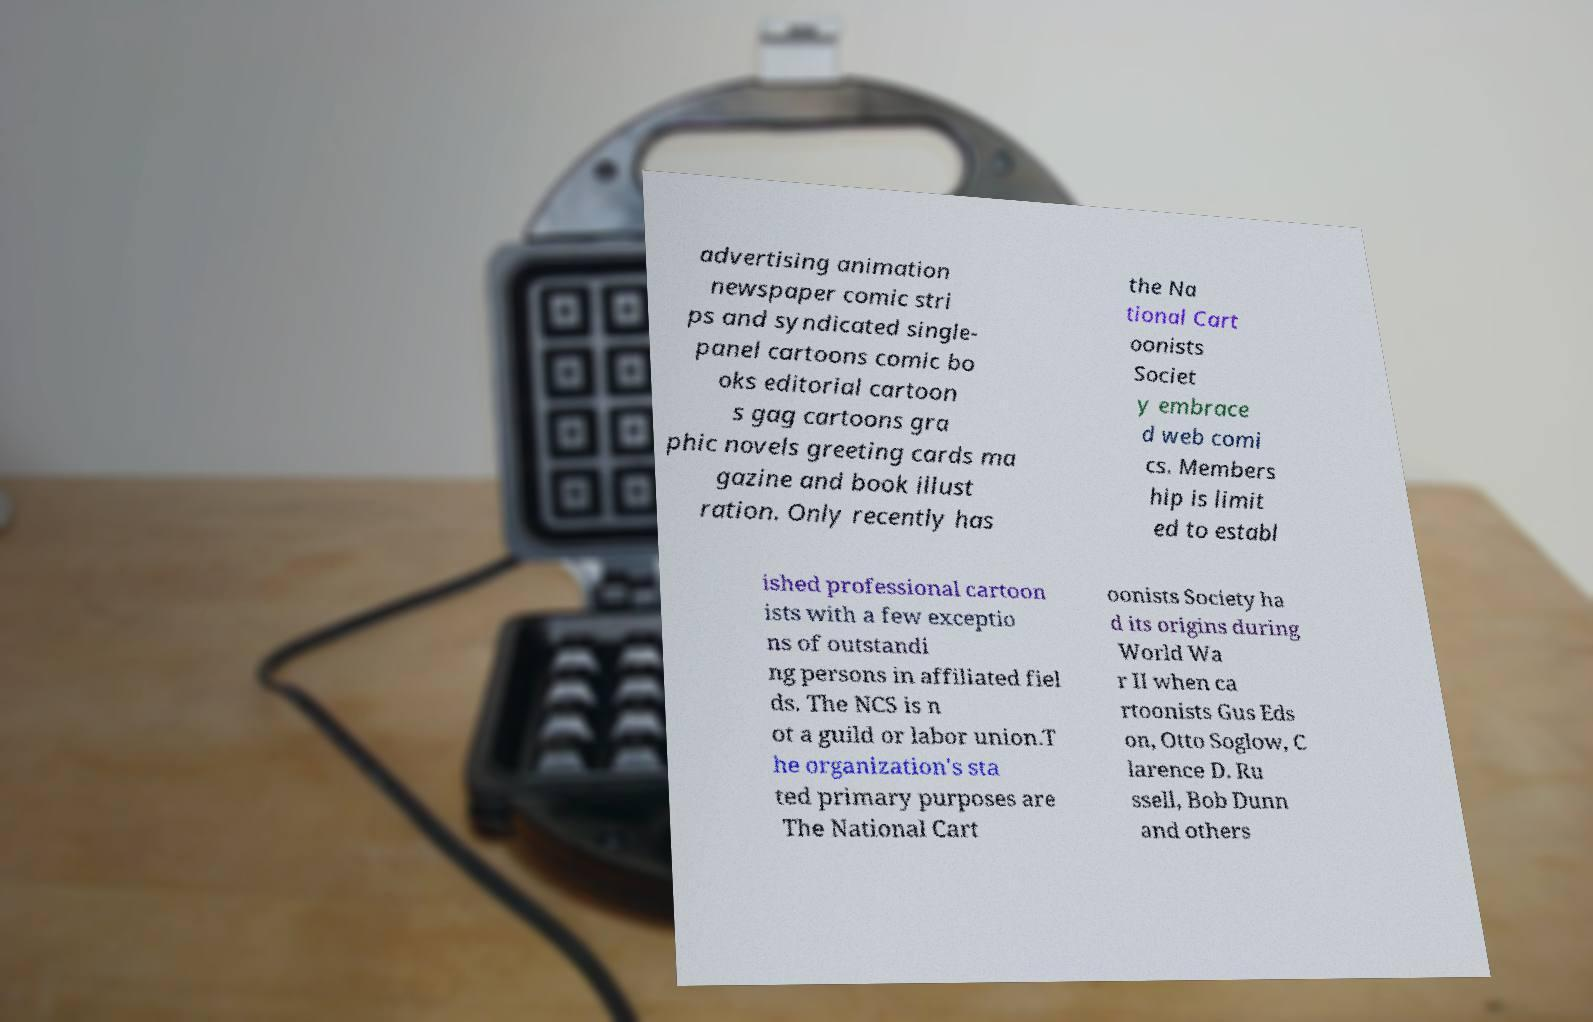Can you read and provide the text displayed in the image?This photo seems to have some interesting text. Can you extract and type it out for me? advertising animation newspaper comic stri ps and syndicated single- panel cartoons comic bo oks editorial cartoon s gag cartoons gra phic novels greeting cards ma gazine and book illust ration. Only recently has the Na tional Cart oonists Societ y embrace d web comi cs. Members hip is limit ed to establ ished professional cartoon ists with a few exceptio ns of outstandi ng persons in affiliated fiel ds. The NCS is n ot a guild or labor union.T he organization's sta ted primary purposes are The National Cart oonists Society ha d its origins during World Wa r II when ca rtoonists Gus Eds on, Otto Soglow, C larence D. Ru ssell, Bob Dunn and others 